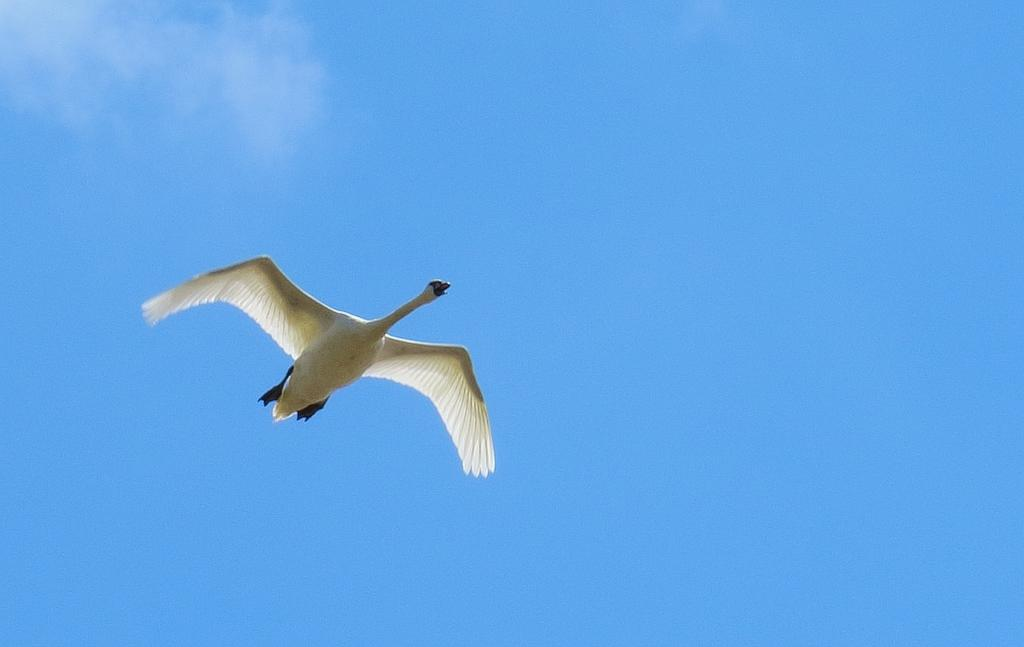What is the main subject of the image? The main subject of the image is a bird flying. What can be seen in the background of the image? The sky is visible in the background of the image. How many fish can be seen swimming in the image? There are no fish present in the image; it features a bird flying in the sky. What type of goat is visible in the image? There is no goat present in the image; it only features a bird flying in the sky. 